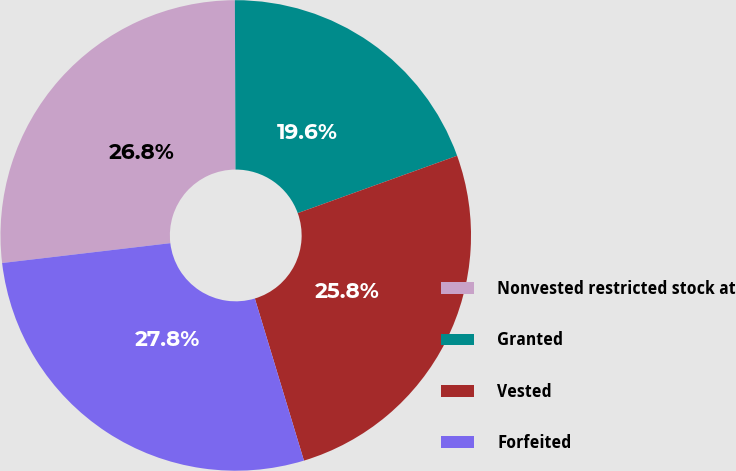Convert chart. <chart><loc_0><loc_0><loc_500><loc_500><pie_chart><fcel>Nonvested restricted stock at<fcel>Granted<fcel>Vested<fcel>Forfeited<nl><fcel>26.81%<fcel>19.56%<fcel>25.82%<fcel>27.81%<nl></chart> 